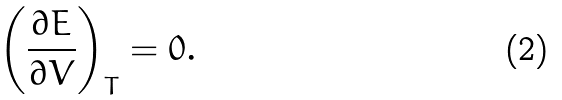Convert formula to latex. <formula><loc_0><loc_0><loc_500><loc_500>\left ( \frac { \partial E } { \partial V } \right ) _ { T } = 0 .</formula> 